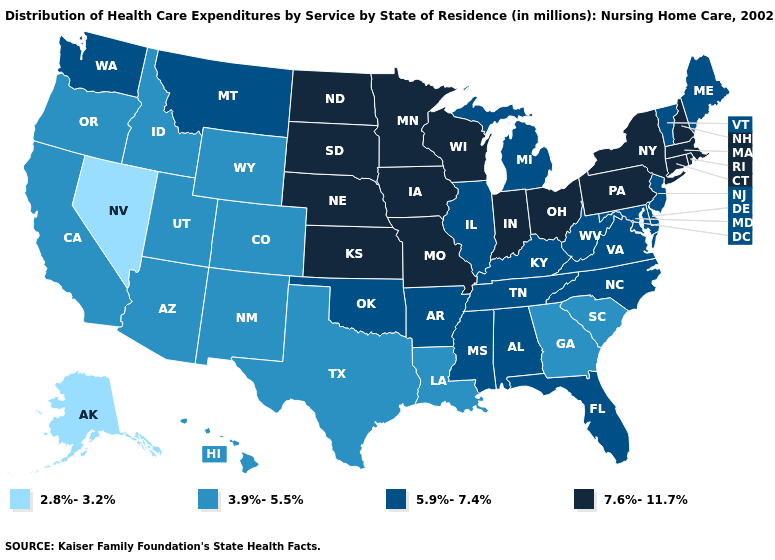Does Washington have the highest value in the West?
Be succinct. Yes. Name the states that have a value in the range 3.9%-5.5%?
Be succinct. Arizona, California, Colorado, Georgia, Hawaii, Idaho, Louisiana, New Mexico, Oregon, South Carolina, Texas, Utah, Wyoming. How many symbols are there in the legend?
Give a very brief answer. 4. Name the states that have a value in the range 3.9%-5.5%?
Give a very brief answer. Arizona, California, Colorado, Georgia, Hawaii, Idaho, Louisiana, New Mexico, Oregon, South Carolina, Texas, Utah, Wyoming. Name the states that have a value in the range 5.9%-7.4%?
Write a very short answer. Alabama, Arkansas, Delaware, Florida, Illinois, Kentucky, Maine, Maryland, Michigan, Mississippi, Montana, New Jersey, North Carolina, Oklahoma, Tennessee, Vermont, Virginia, Washington, West Virginia. What is the lowest value in the USA?
Be succinct. 2.8%-3.2%. Among the states that border New Mexico , which have the lowest value?
Answer briefly. Arizona, Colorado, Texas, Utah. Does Mississippi have the same value as Indiana?
Answer briefly. No. What is the value of Mississippi?
Concise answer only. 5.9%-7.4%. Is the legend a continuous bar?
Quick response, please. No. Which states have the lowest value in the USA?
Give a very brief answer. Alaska, Nevada. Does Maine have the same value as Kentucky?
Be succinct. Yes. What is the value of Kansas?
Short answer required. 7.6%-11.7%. What is the value of Mississippi?
Be succinct. 5.9%-7.4%. Which states have the lowest value in the USA?
Give a very brief answer. Alaska, Nevada. 